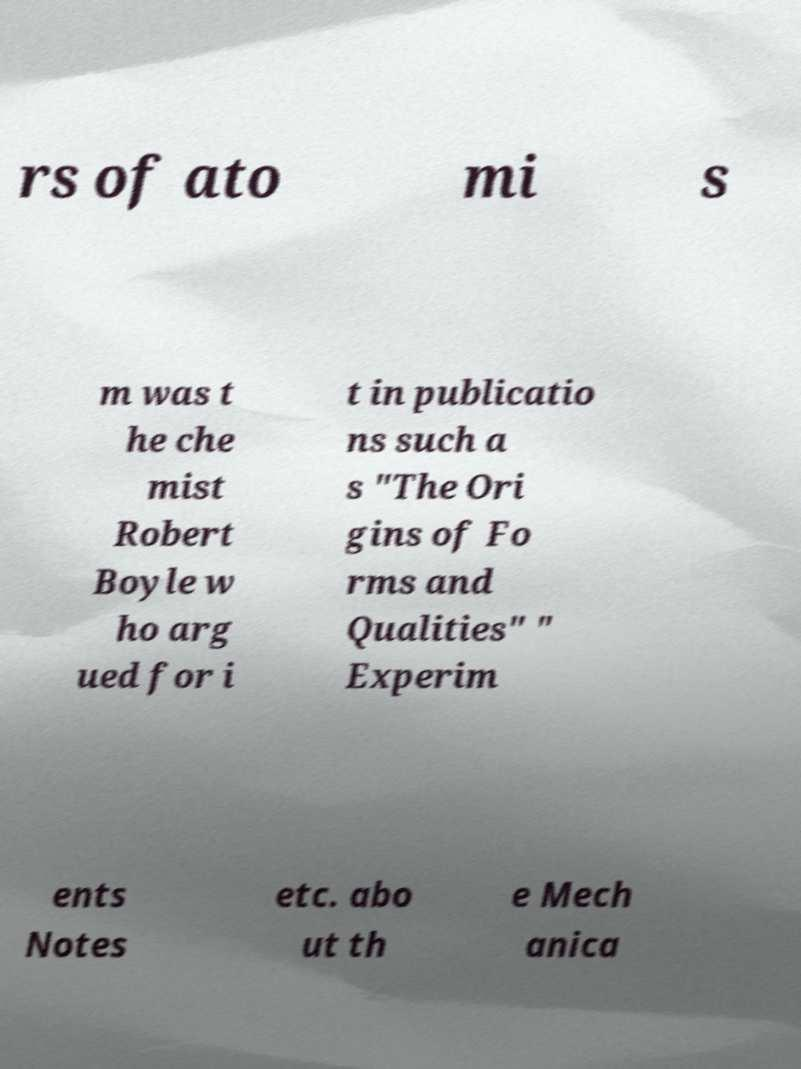What messages or text are displayed in this image? I need them in a readable, typed format. rs of ato mi s m was t he che mist Robert Boyle w ho arg ued for i t in publicatio ns such a s "The Ori gins of Fo rms and Qualities" " Experim ents Notes etc. abo ut th e Mech anica 